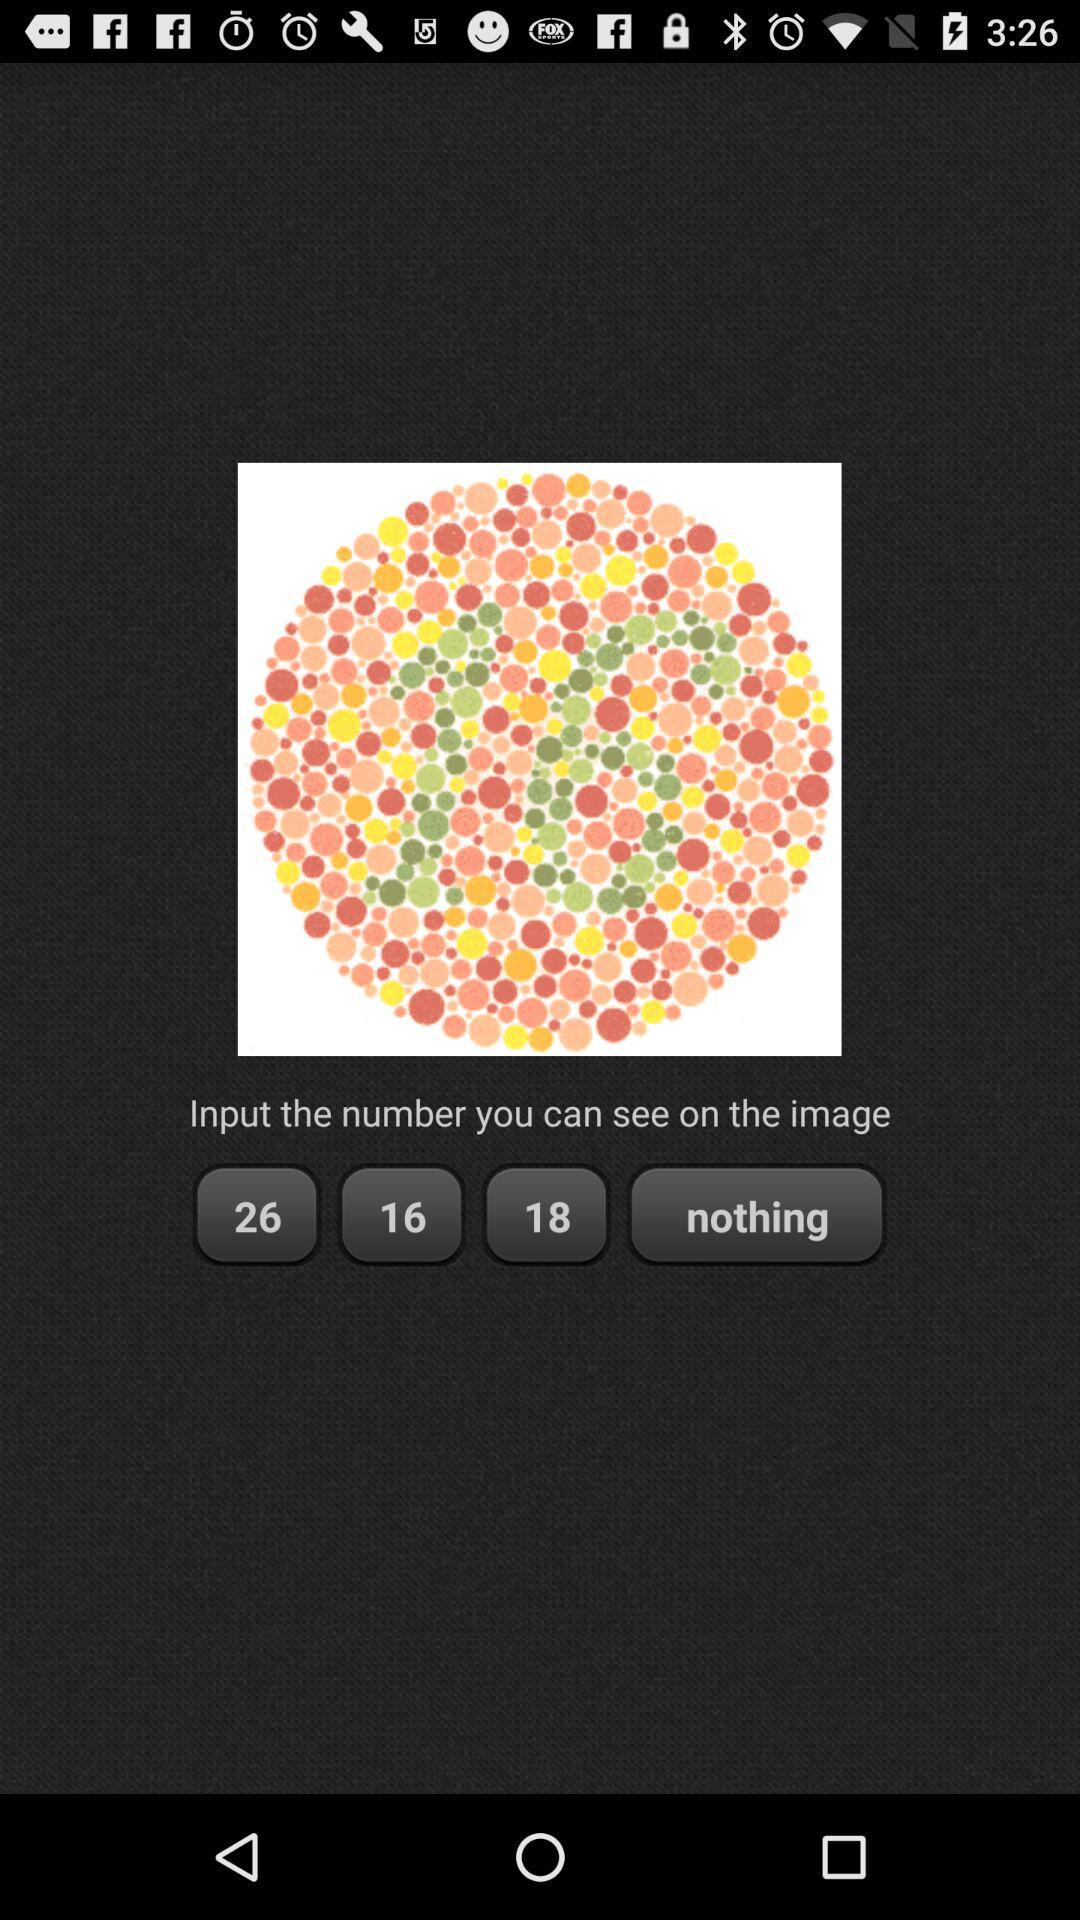What is the number on the image? The number is 16. 